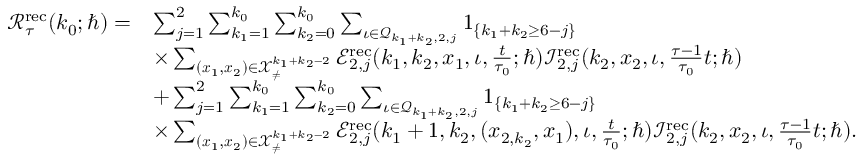Convert formula to latex. <formula><loc_0><loc_0><loc_500><loc_500>\begin{array} { r l } { \mathcal { R } _ { \tau } ^ { r e c } ( k _ { 0 } ; \hbar { ) } = } & { \sum _ { j = 1 } ^ { 2 } \sum _ { k _ { 1 } = 1 } ^ { k _ { 0 } } \sum _ { k _ { 2 } = 0 } ^ { k _ { 0 } } \sum _ { \iota \in \mathcal { Q } _ { k _ { 1 } + k _ { 2 } , 2 , j } } 1 _ { \{ k _ { 1 } + k _ { 2 } \geq 6 - j \} } } \\ & { \times \sum _ { ( x _ { 1 } , x _ { 2 } ) \in \mathcal { X } _ { \neq } ^ { k _ { 1 } + k _ { 2 } - 2 } } \mathcal { E } _ { 2 , j } ^ { r e c } ( k _ { 1 } , k _ { 2 } , x _ { 1 } , \iota , \frac { t } { \tau _ { 0 } } ; \hbar { ) } \mathcal { I } _ { 2 , j } ^ { r e c } ( k _ { 2 } , x _ { 2 } , \iota , \frac { \tau - 1 } { \tau _ { 0 } } t ; \hbar { ) } } \\ & { + \sum _ { j = 1 } ^ { 2 } \sum _ { k _ { 1 } = 1 } ^ { k _ { 0 } } \sum _ { k _ { 2 } = 0 } ^ { k _ { 0 } } \sum _ { \iota \in \mathcal { Q } _ { k _ { 1 } + k _ { 2 } , 2 , j } } 1 _ { \{ k _ { 1 } + k _ { 2 } \geq 6 - j \} } } \\ & { \times \sum _ { ( x _ { 1 } , x _ { 2 } ) \in \mathcal { X } _ { \neq } ^ { k _ { 1 } + k _ { 2 } - 2 } } \mathcal { E } _ { 2 , j } ^ { r e c } ( k _ { 1 } + 1 , k _ { 2 } , ( x _ { 2 , k _ { 2 } } , x _ { 1 } ) , \iota , \frac { t } { \tau _ { 0 } } ; \hbar { ) } \mathcal { I } _ { 2 , j } ^ { r e c } ( k _ { 2 } , x _ { 2 } , \iota , \frac { \tau - 1 } { \tau _ { 0 } } t ; \hbar { ) } . } \end{array}</formula> 